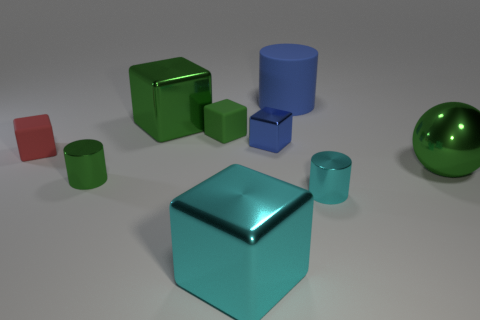Subtract all blue cubes. How many cubes are left? 4 Subtract all blue shiny cubes. How many cubes are left? 4 Subtract all yellow cubes. Subtract all cyan cylinders. How many cubes are left? 5 Add 1 cyan things. How many objects exist? 10 Subtract all spheres. How many objects are left? 8 Subtract all tiny red matte things. Subtract all big matte things. How many objects are left? 7 Add 8 tiny cyan shiny cylinders. How many tiny cyan shiny cylinders are left? 9 Add 1 tiny green metal cylinders. How many tiny green metal cylinders exist? 2 Subtract 0 red spheres. How many objects are left? 9 